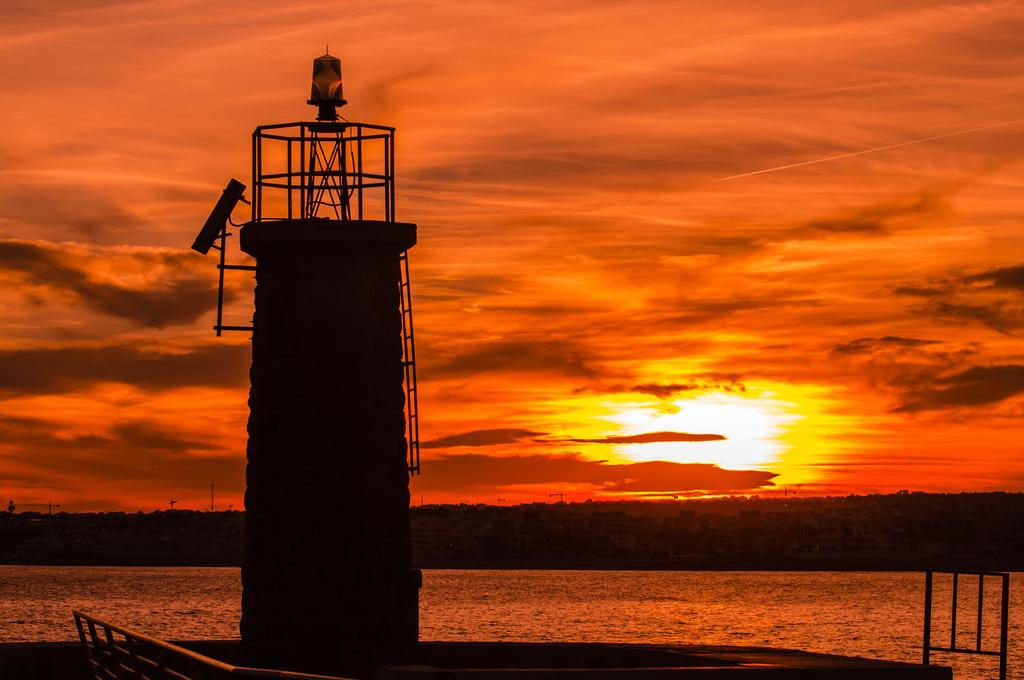What is the main structure visible in the image? There is a lighthouse in the image. What other objects can be seen in the image? There are rods and water visible in the image. What is the condition of the sky in the image? The sky is cloudy in the image. What is the price of the vegetables at the market in the image? There is no market or vegetables present in the image; it features a lighthouse, rods, water, and a cloudy sky. 